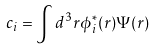<formula> <loc_0><loc_0><loc_500><loc_500>c _ { i } = \int d ^ { 3 } r \phi _ { i } ^ { * } ( { r } ) { \Psi } ( { r } )</formula> 